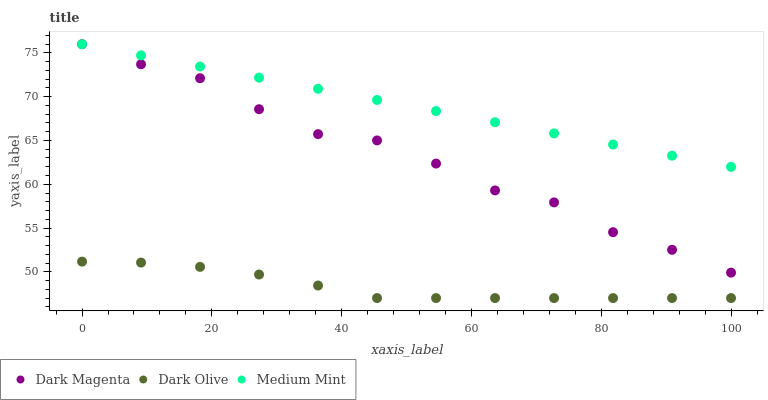Does Dark Olive have the minimum area under the curve?
Answer yes or no. Yes. Does Medium Mint have the maximum area under the curve?
Answer yes or no. Yes. Does Dark Magenta have the minimum area under the curve?
Answer yes or no. No. Does Dark Magenta have the maximum area under the curve?
Answer yes or no. No. Is Medium Mint the smoothest?
Answer yes or no. Yes. Is Dark Magenta the roughest?
Answer yes or no. Yes. Is Dark Olive the smoothest?
Answer yes or no. No. Is Dark Olive the roughest?
Answer yes or no. No. Does Dark Olive have the lowest value?
Answer yes or no. Yes. Does Dark Magenta have the lowest value?
Answer yes or no. No. Does Dark Magenta have the highest value?
Answer yes or no. Yes. Does Dark Olive have the highest value?
Answer yes or no. No. Is Dark Olive less than Medium Mint?
Answer yes or no. Yes. Is Dark Magenta greater than Dark Olive?
Answer yes or no. Yes. Does Medium Mint intersect Dark Magenta?
Answer yes or no. Yes. Is Medium Mint less than Dark Magenta?
Answer yes or no. No. Is Medium Mint greater than Dark Magenta?
Answer yes or no. No. Does Dark Olive intersect Medium Mint?
Answer yes or no. No. 